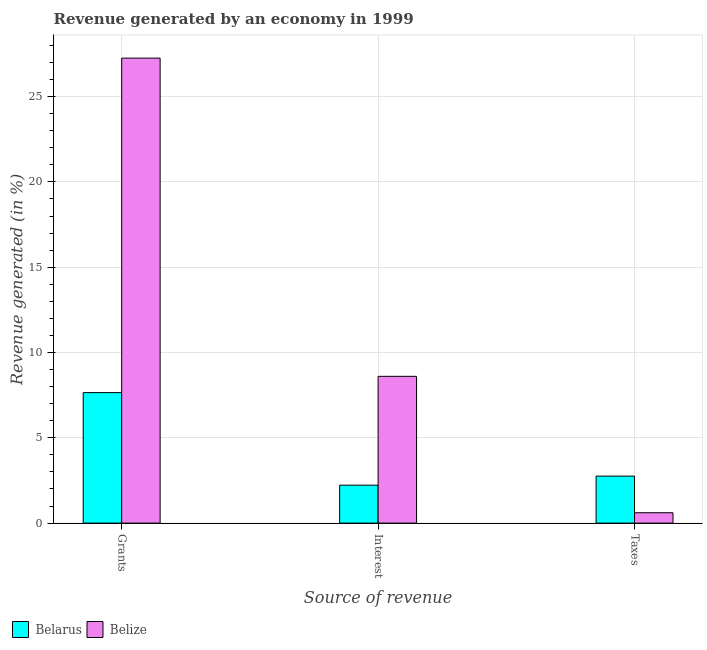Are the number of bars on each tick of the X-axis equal?
Provide a short and direct response. Yes. How many bars are there on the 1st tick from the right?
Offer a very short reply. 2. What is the label of the 2nd group of bars from the left?
Give a very brief answer. Interest. What is the percentage of revenue generated by interest in Belize?
Provide a succinct answer. 8.6. Across all countries, what is the maximum percentage of revenue generated by taxes?
Keep it short and to the point. 2.75. Across all countries, what is the minimum percentage of revenue generated by grants?
Ensure brevity in your answer.  7.65. In which country was the percentage of revenue generated by interest maximum?
Provide a short and direct response. Belize. In which country was the percentage of revenue generated by taxes minimum?
Keep it short and to the point. Belize. What is the total percentage of revenue generated by taxes in the graph?
Your response must be concise. 3.36. What is the difference between the percentage of revenue generated by grants in Belarus and that in Belize?
Give a very brief answer. -19.61. What is the difference between the percentage of revenue generated by interest in Belize and the percentage of revenue generated by grants in Belarus?
Provide a succinct answer. 0.95. What is the average percentage of revenue generated by grants per country?
Ensure brevity in your answer.  17.45. What is the difference between the percentage of revenue generated by grants and percentage of revenue generated by taxes in Belarus?
Your answer should be very brief. 4.9. In how many countries, is the percentage of revenue generated by interest greater than 27 %?
Your answer should be very brief. 0. What is the ratio of the percentage of revenue generated by taxes in Belarus to that in Belize?
Keep it short and to the point. 4.52. Is the percentage of revenue generated by interest in Belize less than that in Belarus?
Keep it short and to the point. No. Is the difference between the percentage of revenue generated by taxes in Belize and Belarus greater than the difference between the percentage of revenue generated by grants in Belize and Belarus?
Provide a short and direct response. No. What is the difference between the highest and the second highest percentage of revenue generated by interest?
Give a very brief answer. 6.38. What is the difference between the highest and the lowest percentage of revenue generated by interest?
Ensure brevity in your answer.  6.38. Is the sum of the percentage of revenue generated by taxes in Belarus and Belize greater than the maximum percentage of revenue generated by grants across all countries?
Offer a terse response. No. What does the 2nd bar from the left in Grants represents?
Keep it short and to the point. Belize. What does the 1st bar from the right in Taxes represents?
Your answer should be very brief. Belize. Are all the bars in the graph horizontal?
Ensure brevity in your answer.  No. How many countries are there in the graph?
Your answer should be very brief. 2. What is the difference between two consecutive major ticks on the Y-axis?
Offer a very short reply. 5. Does the graph contain grids?
Ensure brevity in your answer.  Yes. Where does the legend appear in the graph?
Your answer should be compact. Bottom left. How many legend labels are there?
Offer a very short reply. 2. What is the title of the graph?
Make the answer very short. Revenue generated by an economy in 1999. What is the label or title of the X-axis?
Your response must be concise. Source of revenue. What is the label or title of the Y-axis?
Your response must be concise. Revenue generated (in %). What is the Revenue generated (in %) of Belarus in Grants?
Your answer should be very brief. 7.65. What is the Revenue generated (in %) of Belize in Grants?
Provide a short and direct response. 27.26. What is the Revenue generated (in %) of Belarus in Interest?
Your answer should be very brief. 2.22. What is the Revenue generated (in %) of Belize in Interest?
Your answer should be compact. 8.6. What is the Revenue generated (in %) in Belarus in Taxes?
Your answer should be very brief. 2.75. What is the Revenue generated (in %) in Belize in Taxes?
Offer a very short reply. 0.61. Across all Source of revenue, what is the maximum Revenue generated (in %) in Belarus?
Your answer should be very brief. 7.65. Across all Source of revenue, what is the maximum Revenue generated (in %) of Belize?
Your response must be concise. 27.26. Across all Source of revenue, what is the minimum Revenue generated (in %) of Belarus?
Offer a terse response. 2.22. Across all Source of revenue, what is the minimum Revenue generated (in %) of Belize?
Your answer should be very brief. 0.61. What is the total Revenue generated (in %) of Belarus in the graph?
Make the answer very short. 12.63. What is the total Revenue generated (in %) in Belize in the graph?
Make the answer very short. 36.47. What is the difference between the Revenue generated (in %) of Belarus in Grants and that in Interest?
Your answer should be compact. 5.43. What is the difference between the Revenue generated (in %) in Belize in Grants and that in Interest?
Provide a succinct answer. 18.65. What is the difference between the Revenue generated (in %) of Belarus in Grants and that in Taxes?
Give a very brief answer. 4.89. What is the difference between the Revenue generated (in %) of Belize in Grants and that in Taxes?
Offer a very short reply. 26.65. What is the difference between the Revenue generated (in %) in Belarus in Interest and that in Taxes?
Provide a succinct answer. -0.53. What is the difference between the Revenue generated (in %) in Belize in Interest and that in Taxes?
Your response must be concise. 7.99. What is the difference between the Revenue generated (in %) of Belarus in Grants and the Revenue generated (in %) of Belize in Interest?
Your response must be concise. -0.95. What is the difference between the Revenue generated (in %) of Belarus in Grants and the Revenue generated (in %) of Belize in Taxes?
Provide a short and direct response. 7.04. What is the difference between the Revenue generated (in %) of Belarus in Interest and the Revenue generated (in %) of Belize in Taxes?
Offer a terse response. 1.61. What is the average Revenue generated (in %) in Belarus per Source of revenue?
Provide a short and direct response. 4.21. What is the average Revenue generated (in %) of Belize per Source of revenue?
Make the answer very short. 12.16. What is the difference between the Revenue generated (in %) of Belarus and Revenue generated (in %) of Belize in Grants?
Offer a very short reply. -19.61. What is the difference between the Revenue generated (in %) in Belarus and Revenue generated (in %) in Belize in Interest?
Provide a succinct answer. -6.38. What is the difference between the Revenue generated (in %) in Belarus and Revenue generated (in %) in Belize in Taxes?
Keep it short and to the point. 2.15. What is the ratio of the Revenue generated (in %) in Belarus in Grants to that in Interest?
Make the answer very short. 3.44. What is the ratio of the Revenue generated (in %) of Belize in Grants to that in Interest?
Offer a very short reply. 3.17. What is the ratio of the Revenue generated (in %) in Belarus in Grants to that in Taxes?
Offer a terse response. 2.78. What is the ratio of the Revenue generated (in %) in Belize in Grants to that in Taxes?
Give a very brief answer. 44.73. What is the ratio of the Revenue generated (in %) in Belarus in Interest to that in Taxes?
Your answer should be very brief. 0.81. What is the ratio of the Revenue generated (in %) of Belize in Interest to that in Taxes?
Give a very brief answer. 14.12. What is the difference between the highest and the second highest Revenue generated (in %) of Belarus?
Give a very brief answer. 4.89. What is the difference between the highest and the second highest Revenue generated (in %) of Belize?
Provide a short and direct response. 18.65. What is the difference between the highest and the lowest Revenue generated (in %) of Belarus?
Give a very brief answer. 5.43. What is the difference between the highest and the lowest Revenue generated (in %) of Belize?
Keep it short and to the point. 26.65. 